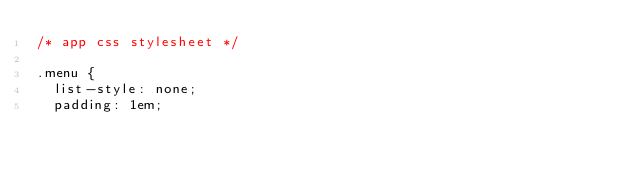<code> <loc_0><loc_0><loc_500><loc_500><_CSS_>/* app css stylesheet */

.menu {
  list-style: none;
  padding: 1em;</code> 